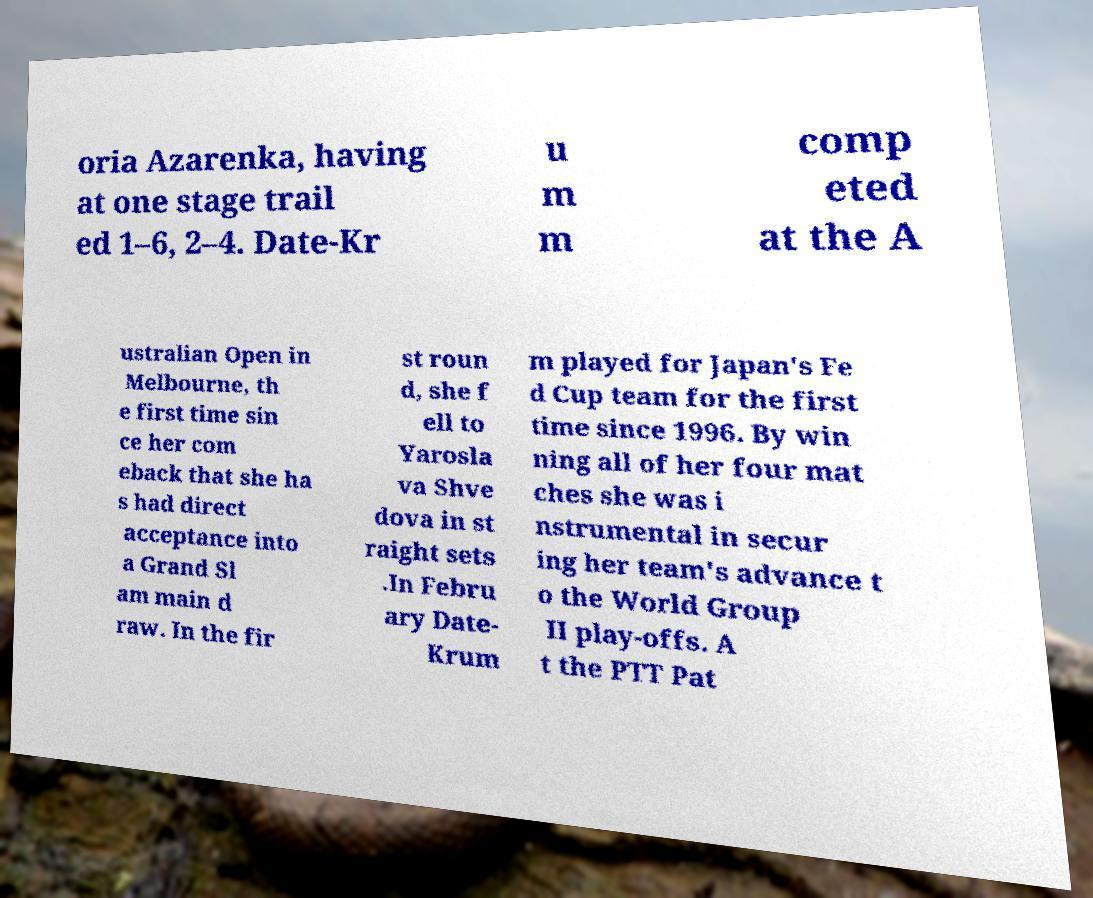Please identify and transcribe the text found in this image. oria Azarenka, having at one stage trail ed 1–6, 2–4. Date-Kr u m m comp eted at the A ustralian Open in Melbourne, th e first time sin ce her com eback that she ha s had direct acceptance into a Grand Sl am main d raw. In the fir st roun d, she f ell to Yarosla va Shve dova in st raight sets .In Febru ary Date- Krum m played for Japan's Fe d Cup team for the first time since 1996. By win ning all of her four mat ches she was i nstrumental in secur ing her team's advance t o the World Group II play-offs. A t the PTT Pat 